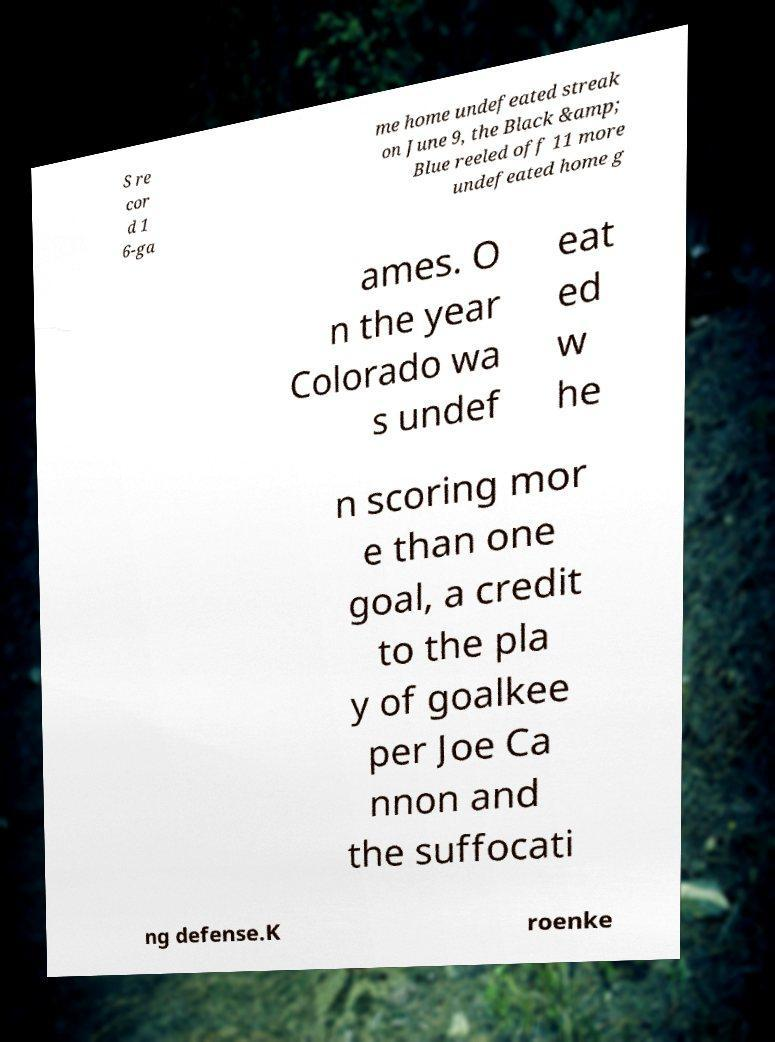Can you read and provide the text displayed in the image?This photo seems to have some interesting text. Can you extract and type it out for me? S re cor d 1 6-ga me home undefeated streak on June 9, the Black &amp; Blue reeled off 11 more undefeated home g ames. O n the year Colorado wa s undef eat ed w he n scoring mor e than one goal, a credit to the pla y of goalkee per Joe Ca nnon and the suffocati ng defense.K roenke 